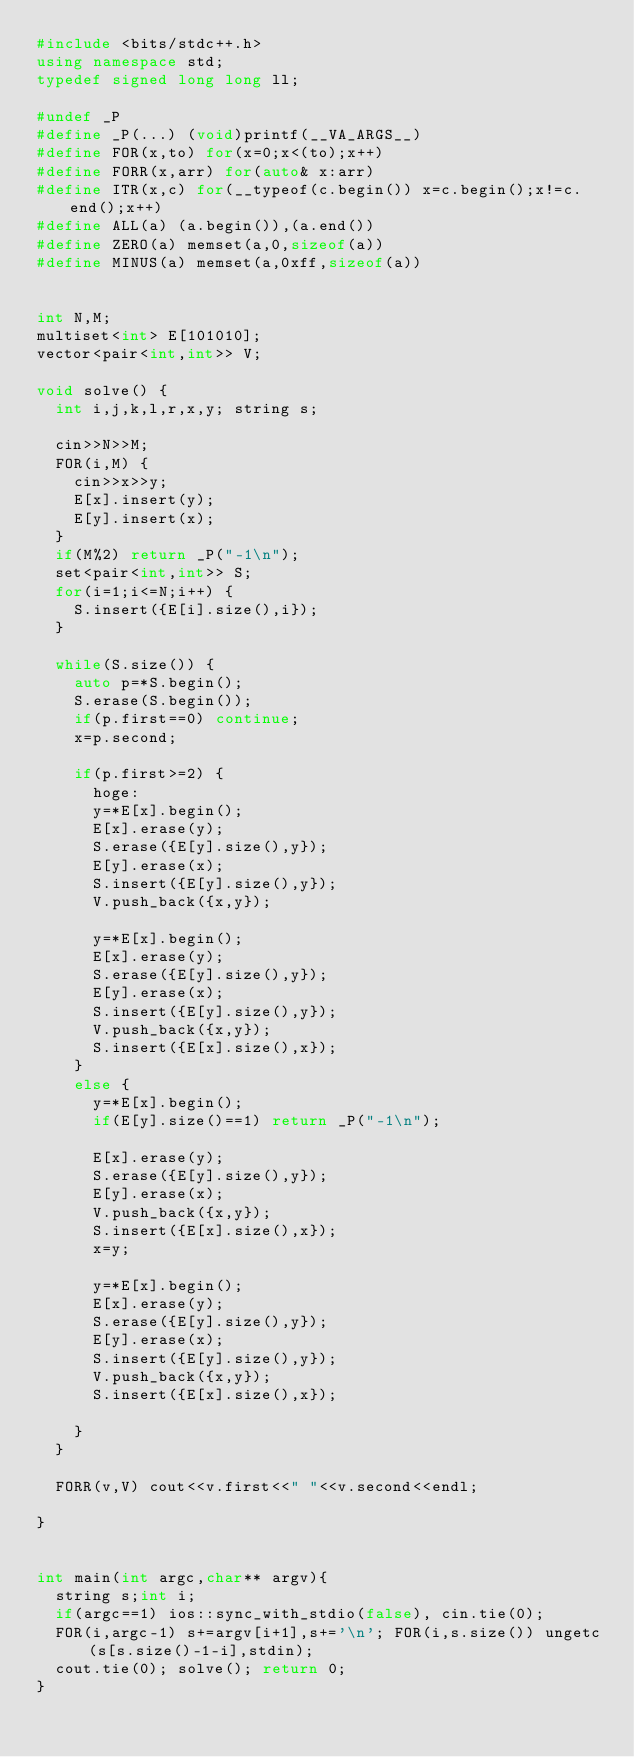Convert code to text. <code><loc_0><loc_0><loc_500><loc_500><_C++_>#include <bits/stdc++.h>
using namespace std;
typedef signed long long ll;

#undef _P
#define _P(...) (void)printf(__VA_ARGS__)
#define FOR(x,to) for(x=0;x<(to);x++)
#define FORR(x,arr) for(auto& x:arr)
#define ITR(x,c) for(__typeof(c.begin()) x=c.begin();x!=c.end();x++)
#define ALL(a) (a.begin()),(a.end())
#define ZERO(a) memset(a,0,sizeof(a))
#define MINUS(a) memset(a,0xff,sizeof(a))


int N,M;
multiset<int> E[101010];
vector<pair<int,int>> V;

void solve() {
	int i,j,k,l,r,x,y; string s;
	
	cin>>N>>M;
	FOR(i,M) {
		cin>>x>>y;
		E[x].insert(y);
		E[y].insert(x);
	}
	if(M%2) return _P("-1\n");
	set<pair<int,int>> S;
	for(i=1;i<=N;i++) {
		S.insert({E[i].size(),i});
	}
	
	while(S.size()) {
		auto p=*S.begin();
		S.erase(S.begin());
		if(p.first==0) continue;
		x=p.second;
		
		if(p.first>=2) {
			hoge:
			y=*E[x].begin();
			E[x].erase(y);
			S.erase({E[y].size(),y});
			E[y].erase(x);
			S.insert({E[y].size(),y});
			V.push_back({x,y});
			
			y=*E[x].begin();
			E[x].erase(y);
			S.erase({E[y].size(),y});
			E[y].erase(x);
			S.insert({E[y].size(),y});
			V.push_back({x,y});
			S.insert({E[x].size(),x});
		}
		else {
			y=*E[x].begin();
			if(E[y].size()==1) return _P("-1\n");
			
			E[x].erase(y);
			S.erase({E[y].size(),y});
			E[y].erase(x);
			V.push_back({x,y});
			S.insert({E[x].size(),x});
			x=y;
			
			y=*E[x].begin();
			E[x].erase(y);
			S.erase({E[y].size(),y});
			E[y].erase(x);
			S.insert({E[y].size(),y});
			V.push_back({x,y});
			S.insert({E[x].size(),x});
			
		}
	}
	
	FORR(v,V) cout<<v.first<<" "<<v.second<<endl;
	
}


int main(int argc,char** argv){
	string s;int i;
	if(argc==1) ios::sync_with_stdio(false), cin.tie(0);
	FOR(i,argc-1) s+=argv[i+1],s+='\n'; FOR(i,s.size()) ungetc(s[s.size()-1-i],stdin);
	cout.tie(0); solve(); return 0;
}
</code> 